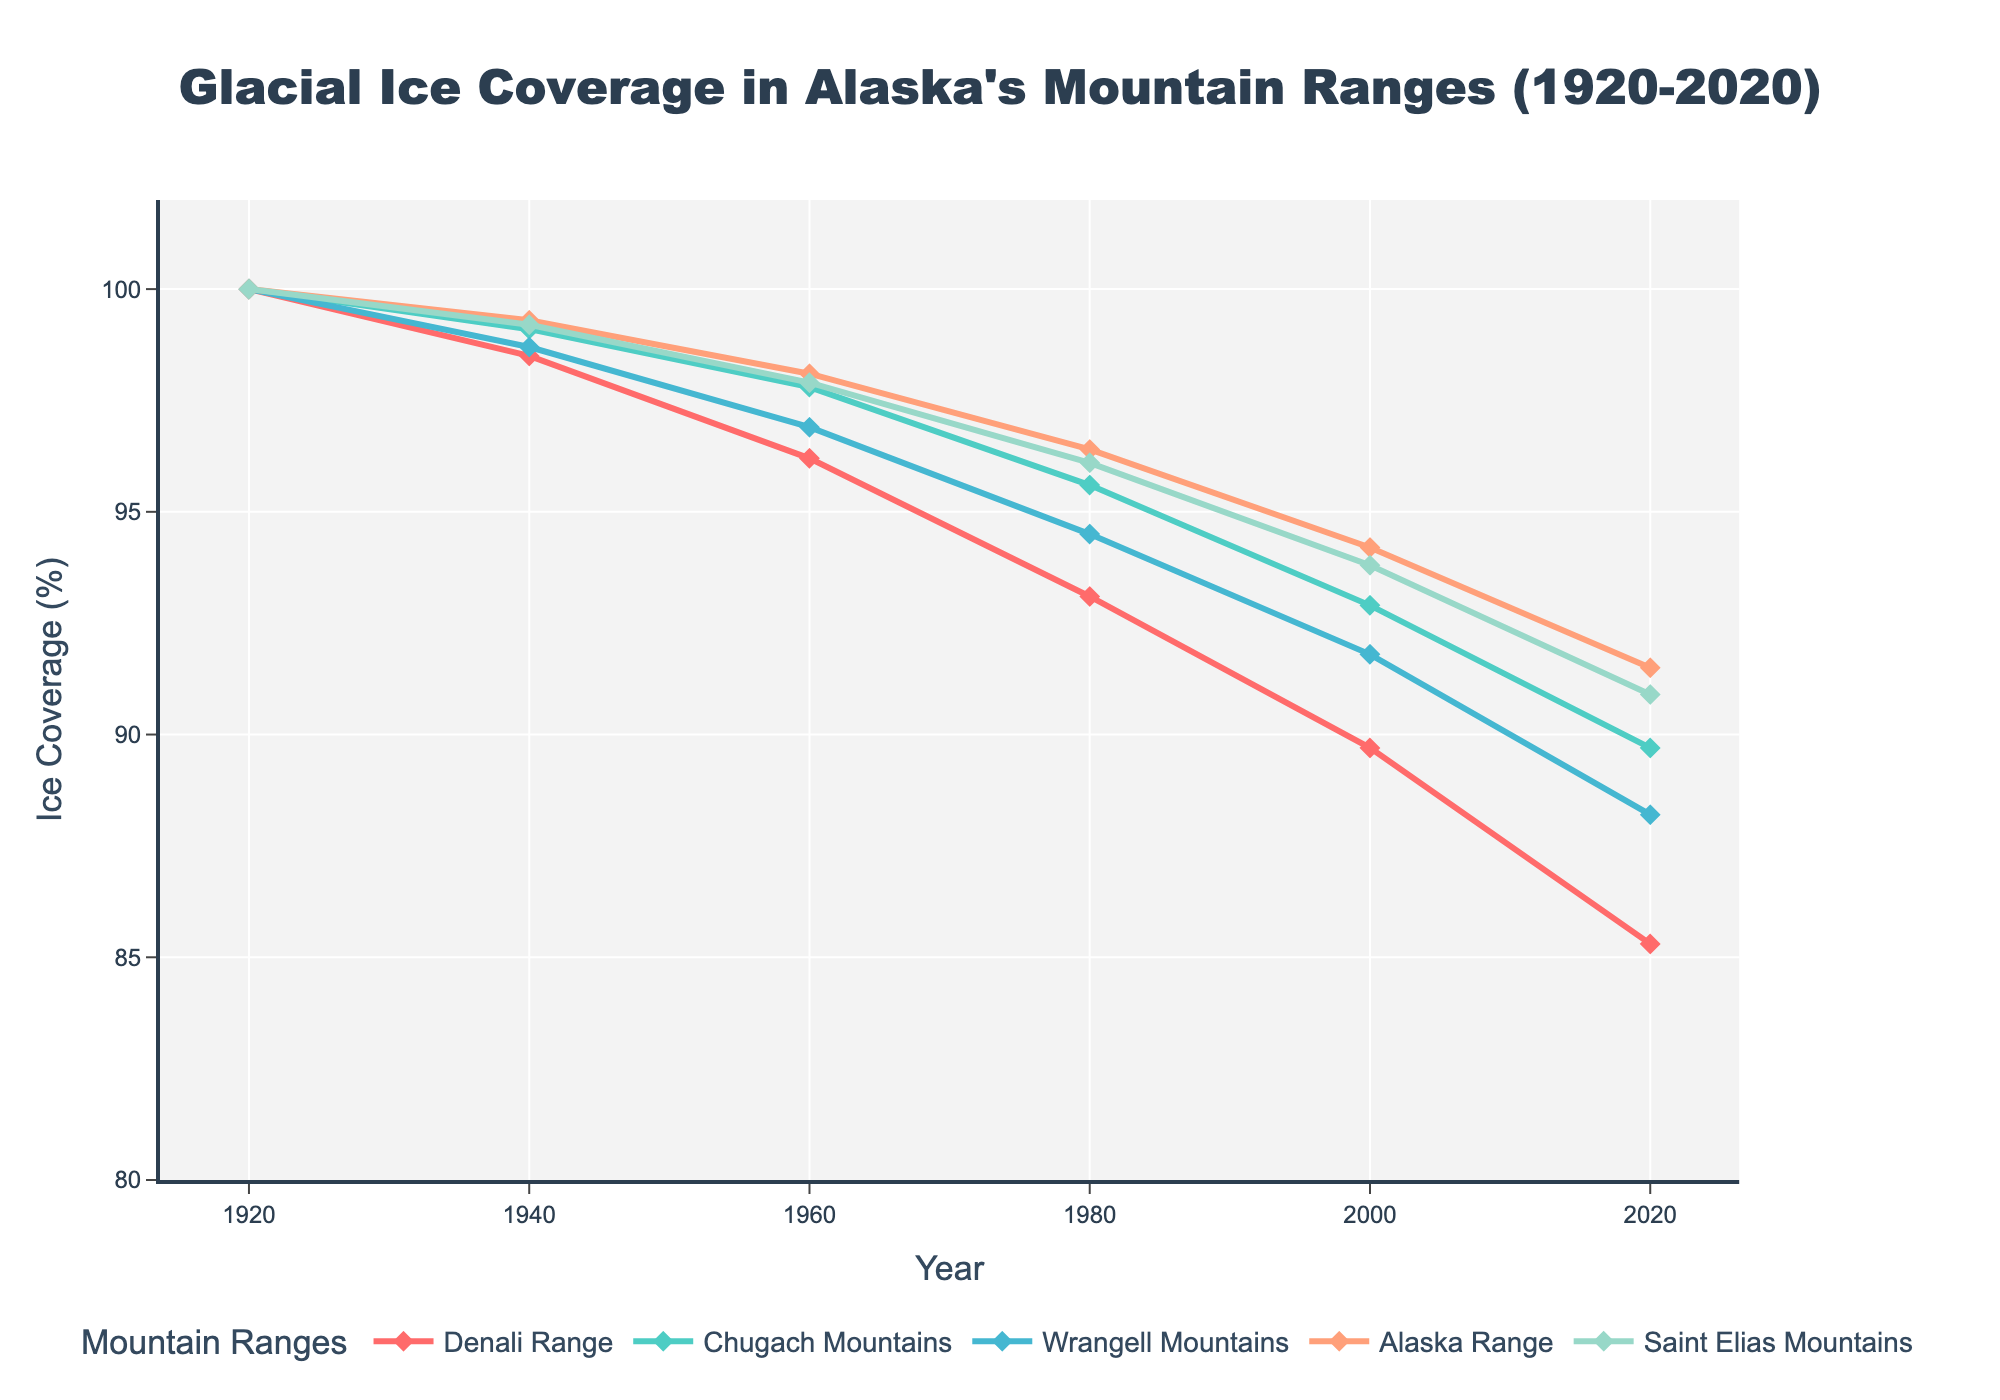What was the overall trend in ice coverage for the Denali Range from 1920 to 2020? The Denali Range shows a consistent decreasing trend in ice coverage from 100% in 1920 to 85.3% in 2020.
Answer: A decreasing trend Which mountain range experienced the least decrease in ice coverage percentage from 1920 to 2020? By comparing the ice coverage percentage from 1920 to 2020 for each mountain range, the Chugach Mountains experienced the least decrease, going from 100% to 89.7%.
Answer: Chugach Mountains Between which two decades did the Alaska Range experience the largest drop in ice coverage percentage? By observing the changes in ice coverage for the Alaska Range, the largest drop happened between 1980 (96.4%) and 2000 (94.2%), which is a decrease of 2.2%.
Answer: Between 1980 and 2000 How does the ice coverage change from 1920 to 2020 differ between the Wrangell Mountains and the Saint Elias Mountains? The Wrangell Mountains saw a decrease from 100% to 88.2%, a drop of 11.8%. The Saint Elias Mountains saw a decrease from 100% to 90.9%, a drop of 9.1%. Therefore, the Wrangell Mountains experienced a greater drop.
Answer: Wrangell Mountains experienced a greater drop Which mountain range had the highest ice coverage percentage in the year 1960? By looking at the data for 1960, the Alaska Range had an ice coverage of 98.1%, which is the highest among all the ranges.
Answer: Alaska Range What colors are used to represent the Denali Range and the Alaska Range in the plot? The Denali Range is represented in red, and the Alaska Range is represented in orange.
Answer: Red for Denali Range, Orange for Alaska Range From the visual attributes of the graph, which mountain range had the most stable ice coverage from 1920 to 2020? Observing the trends, the Chugach Mountains had the most stable coverage with the line showing the least steepness, indicating less change.
Answer: Chugach Mountains By how much percentage did the ice coverage decrease in the Chugach Mountains from 1940 to 1960? The ice coverage in the Chugach Mountains decreased from 99.1% in 1940 to 97.8% in 1960, which is a decrease of 1.3%.
Answer: 1.3% Which two mountain ranges had the closest ice coverage percentage in the year 2000? In 2000, the Wrangell Mountains had 91.8% and the Chugach Mountains had 92.9%. The difference between these two is 1.1%, which is the closest among all ranges.
Answer: Wrangell Mountains and Chugach Mountains 